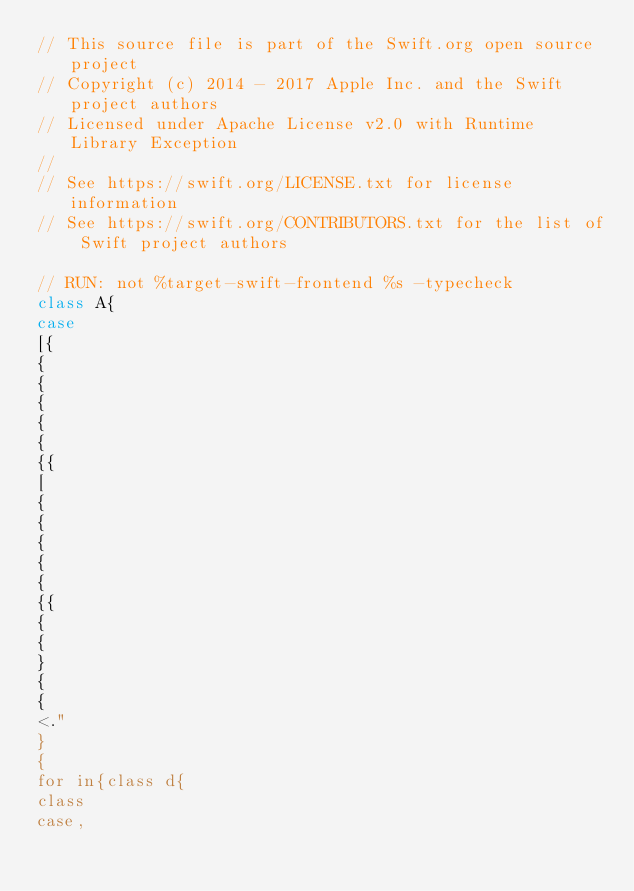<code> <loc_0><loc_0><loc_500><loc_500><_Swift_>// This source file is part of the Swift.org open source project
// Copyright (c) 2014 - 2017 Apple Inc. and the Swift project authors
// Licensed under Apache License v2.0 with Runtime Library Exception
//
// See https://swift.org/LICENSE.txt for license information
// See https://swift.org/CONTRIBUTORS.txt for the list of Swift project authors

// RUN: not %target-swift-frontend %s -typecheck
class A{
case
[{
{
{
{
{
{
{{
[
{
{
{
{
{
{{
{
{
}
{
{
<."
}
{
for in{class d{
class
case,
</code> 